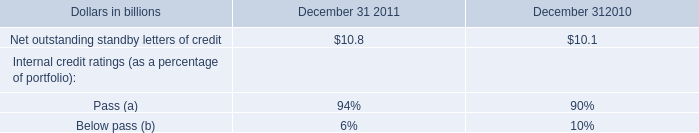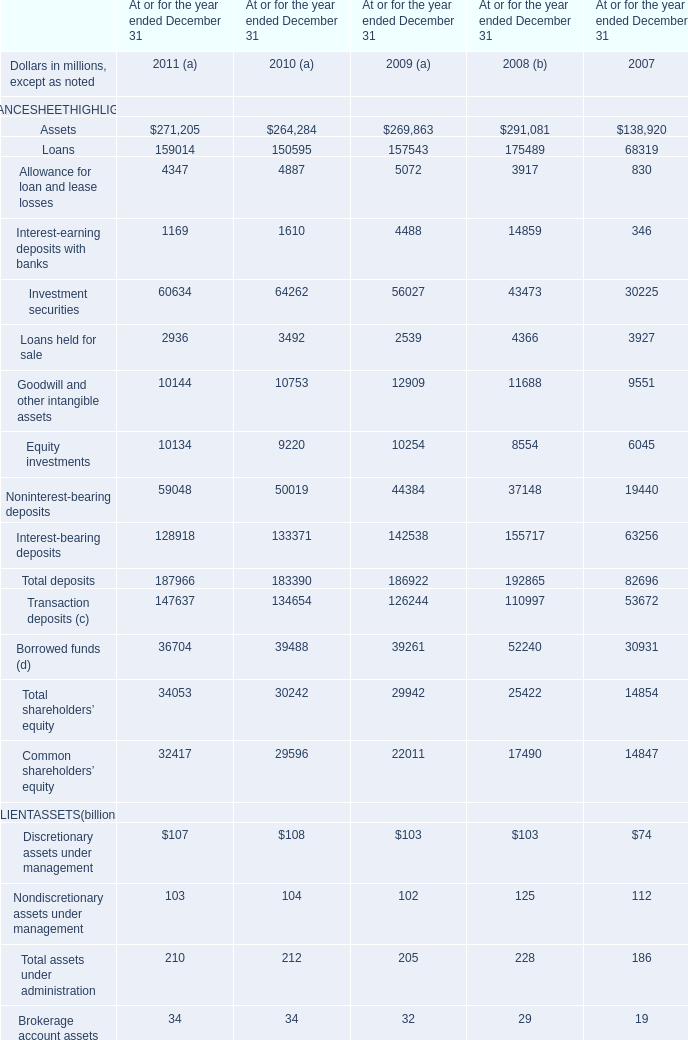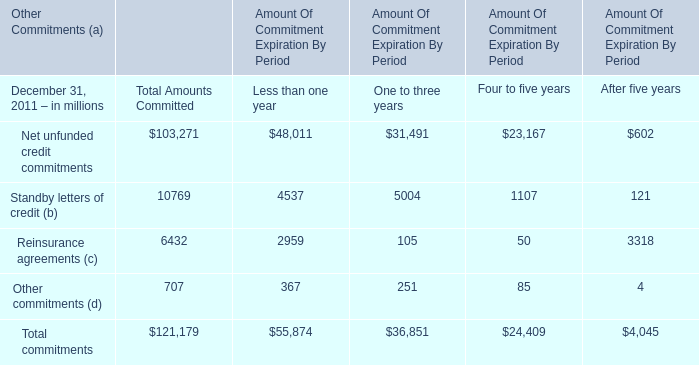What was the total amount of Discretionary assets under management, Nondiscretionary assets under management, Total assets under administration and Brokerage account assets (e) in 2009 for CLIENTASSETS? (in billion) 
Computations: (((103 + 102) + 205) + 32)
Answer: 442.0. 